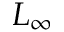Convert formula to latex. <formula><loc_0><loc_0><loc_500><loc_500>L _ { \infty }</formula> 